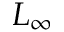Convert formula to latex. <formula><loc_0><loc_0><loc_500><loc_500>L _ { \infty }</formula> 